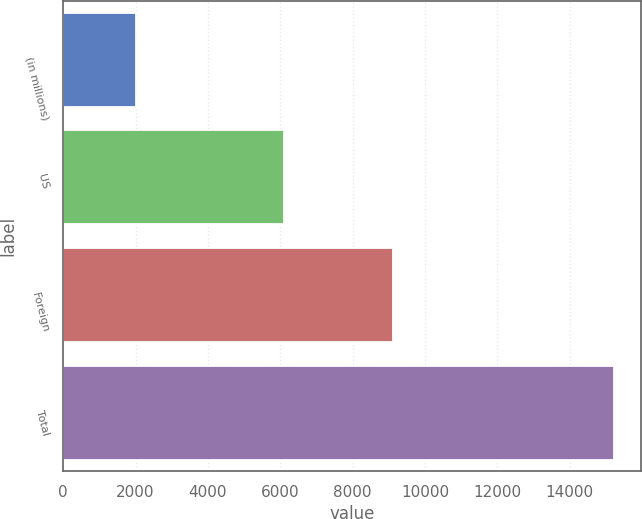Convert chart to OTSL. <chart><loc_0><loc_0><loc_500><loc_500><bar_chart><fcel>(in millions)<fcel>US<fcel>Foreign<fcel>Total<nl><fcel>2005<fcel>6103<fcel>9110<fcel>15213<nl></chart> 